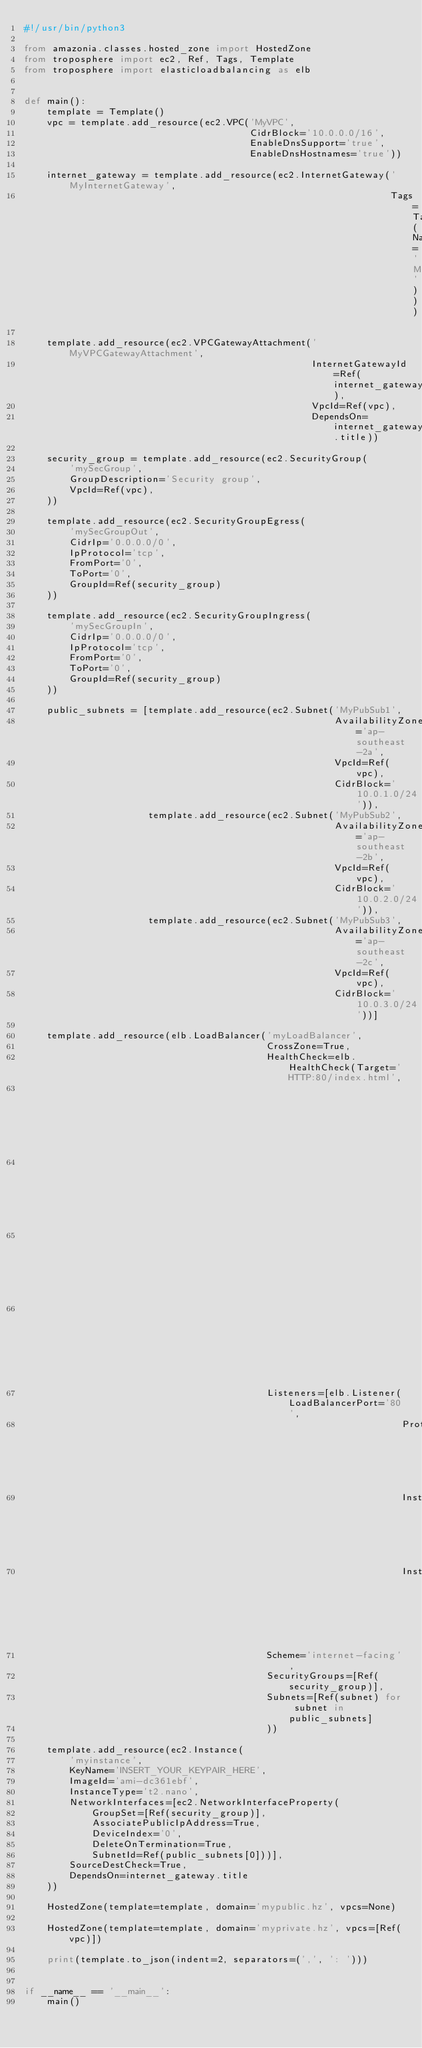<code> <loc_0><loc_0><loc_500><loc_500><_Python_>#!/usr/bin/python3

from amazonia.classes.hosted_zone import HostedZone
from troposphere import ec2, Ref, Tags, Template
from troposphere import elasticloadbalancing as elb


def main():
    template = Template()
    vpc = template.add_resource(ec2.VPC('MyVPC',
                                        CidrBlock='10.0.0.0/16',
                                        EnableDnsSupport='true',
                                        EnableDnsHostnames='true'))

    internet_gateway = template.add_resource(ec2.InternetGateway('MyInternetGateway',
                                                                 Tags=Tags(Name='MyInternetGateway')))

    template.add_resource(ec2.VPCGatewayAttachment('MyVPCGatewayAttachment',
                                                   InternetGatewayId=Ref(internet_gateway),
                                                   VpcId=Ref(vpc),
                                                   DependsOn=internet_gateway.title))

    security_group = template.add_resource(ec2.SecurityGroup(
        'mySecGroup',
        GroupDescription='Security group',
        VpcId=Ref(vpc),
    ))

    template.add_resource(ec2.SecurityGroupEgress(
        'mySecGroupOut',
        CidrIp='0.0.0.0/0',
        IpProtocol='tcp',
        FromPort='0',
        ToPort='0',
        GroupId=Ref(security_group)
    ))

    template.add_resource(ec2.SecurityGroupIngress(
        'mySecGroupIn',
        CidrIp='0.0.0.0/0',
        IpProtocol='tcp',
        FromPort='0',
        ToPort='0',
        GroupId=Ref(security_group)
    ))

    public_subnets = [template.add_resource(ec2.Subnet('MyPubSub1',
                                                       AvailabilityZone='ap-southeast-2a',
                                                       VpcId=Ref(vpc),
                                                       CidrBlock='10.0.1.0/24')),
                      template.add_resource(ec2.Subnet('MyPubSub2',
                                                       AvailabilityZone='ap-southeast-2b',
                                                       VpcId=Ref(vpc),
                                                       CidrBlock='10.0.2.0/24')),
                      template.add_resource(ec2.Subnet('MyPubSub3',
                                                       AvailabilityZone='ap-southeast-2c',
                                                       VpcId=Ref(vpc),
                                                       CidrBlock='10.0.3.0/24'))]

    template.add_resource(elb.LoadBalancer('myLoadBalancer',
                                           CrossZone=True,
                                           HealthCheck=elb.HealthCheck(Target='HTTP:80/index.html',
                                                                       HealthyThreshold='10',
                                                                       UnhealthyThreshold='2',
                                                                       Interval='300',
                                                                       Timeout='60'),
                                           Listeners=[elb.Listener(LoadBalancerPort='80',
                                                                   Protocol='HTTP',
                                                                   InstancePort='80',
                                                                   InstanceProtocol='HTTP')],
                                           Scheme='internet-facing',
                                           SecurityGroups=[Ref(security_group)],
                                           Subnets=[Ref(subnet) for subnet in public_subnets]
                                           ))

    template.add_resource(ec2.Instance(
        'myinstance',
        KeyName='INSERT_YOUR_KEYPAIR_HERE',
        ImageId='ami-dc361ebf',
        InstanceType='t2.nano',
        NetworkInterfaces=[ec2.NetworkInterfaceProperty(
            GroupSet=[Ref(security_group)],
            AssociatePublicIpAddress=True,
            DeviceIndex='0',
            DeleteOnTermination=True,
            SubnetId=Ref(public_subnets[0]))],
        SourceDestCheck=True,
        DependsOn=internet_gateway.title
    ))

    HostedZone(template=template, domain='mypublic.hz', vpcs=None)

    HostedZone(template=template, domain='myprivate.hz', vpcs=[Ref(vpc)])

    print(template.to_json(indent=2, separators=(',', ': ')))


if __name__ == '__main__':
    main()
</code> 